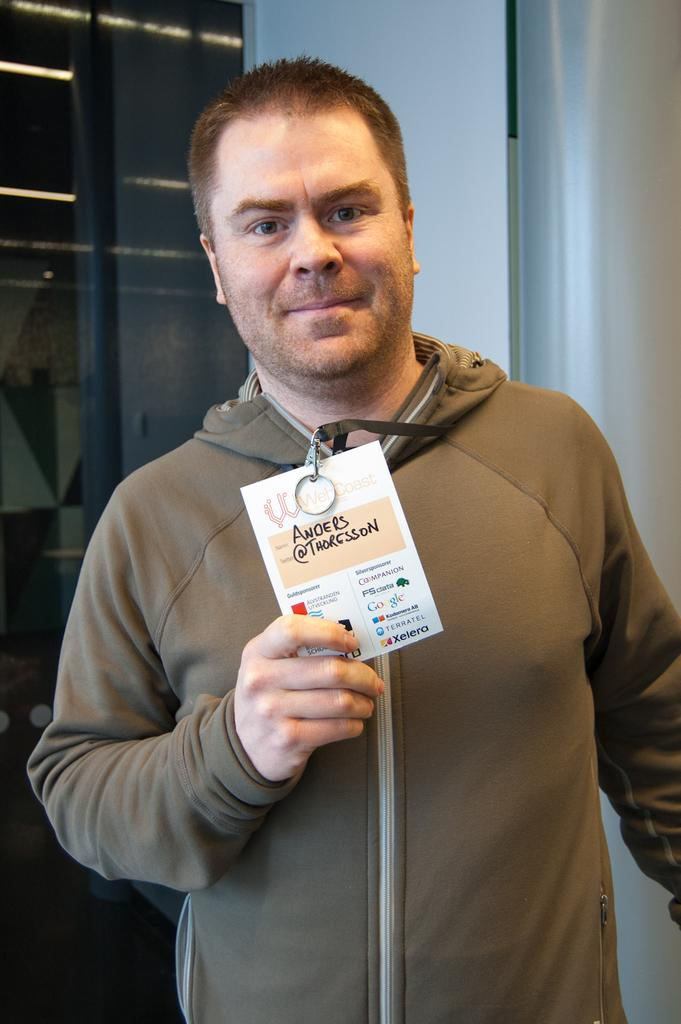Who or what is present in the image? There is a person in the image. What can be observed about the person's attire? The person is wearing clothes. What object is the person holding in their hand? The person is holding a card in their hand. Is the person driving a car in the image? There is no car or indication of driving in the image. 